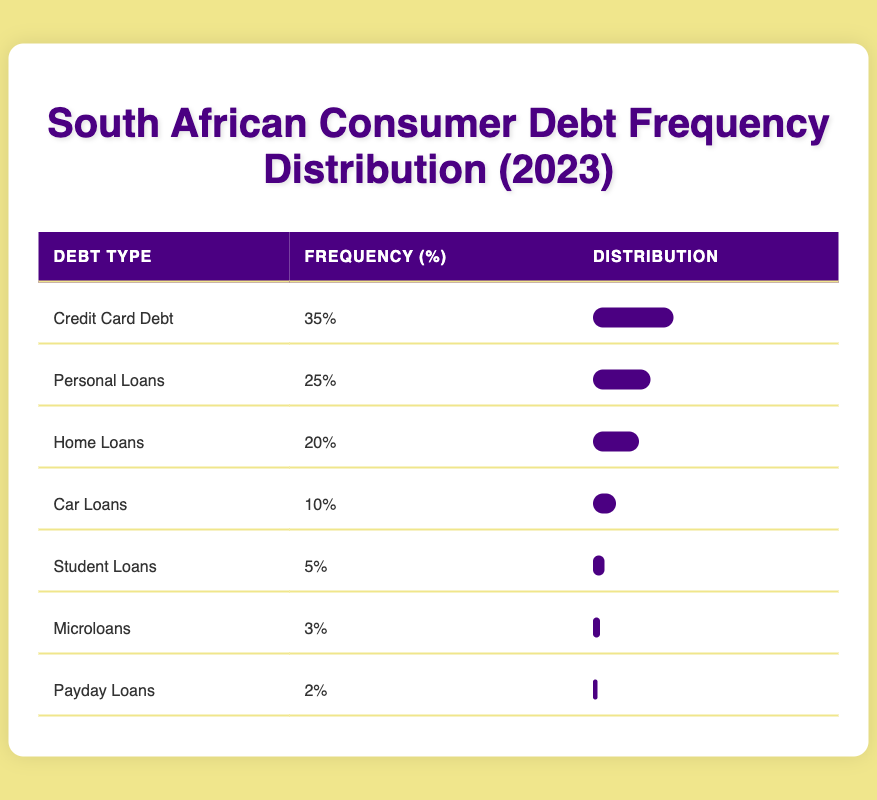What is the most common type of debt among South African consumers? The table shows that "Credit Card Debt" has the highest frequency at 35%.
Answer: Credit Card Debt How many types of debt have a frequency of 10% or greater? The table lists "Credit Card Debt" (35%), "Personal Loans" (25%), "Home Loans" (20%), and "Car Loans" (10%). This totals 4 types of debt.
Answer: 4 What is the total percentage of "Microloans" and "Payday Loans" combined? The frequencies for "Microloans" and "Payday Loans" are 3% and 2%, respectively. Adding these, 3% + 2% equals 5%.
Answer: 5% Is it true that "Student Loans" have a higher frequency than "Microloans"? The frequency for "Student Loans" is 5%, while "Microloans" has a frequency of 3%. Therefore, it is true that "Student Loans" have a higher frequency.
Answer: Yes What percentage of debt types have a frequency less than 5%? The only debt types with frequencies below 5% are "Microloans" (3%) and "Payday Loans" (2%). There are 2 out of 7 total types, meaning the percentage is (2/7)*100 ≈ 28.57%.
Answer: Approximately 28.57% What is the difference in frequency between the most common and the least common debt type? The most common debt type is "Credit Card Debt" at 35%, and the least common is "Payday Loans" at 2%. The difference is 35% - 2% = 33%.
Answer: 33% How does the frequency of "Home Loans" compare to the combined frequency of "Car Loans," "Student Loans," and "Microloans"? "Home Loans" has a frequency of 20%. The combined frequency of "Car Loans" (10%), "Student Loans" (5%), and "Microloans" (3%) totals 10% + 5% + 3% = 18%. Since 20% > 18%, "Home Loans" has a higher frequency.
Answer: Home Loans have a higher frequency Which debt type has the second highest frequency? Looking at the table, "Personal Loans" has the second highest frequency at 25%, positioned below "Credit Card Debt" (35%).
Answer: Personal Loans 